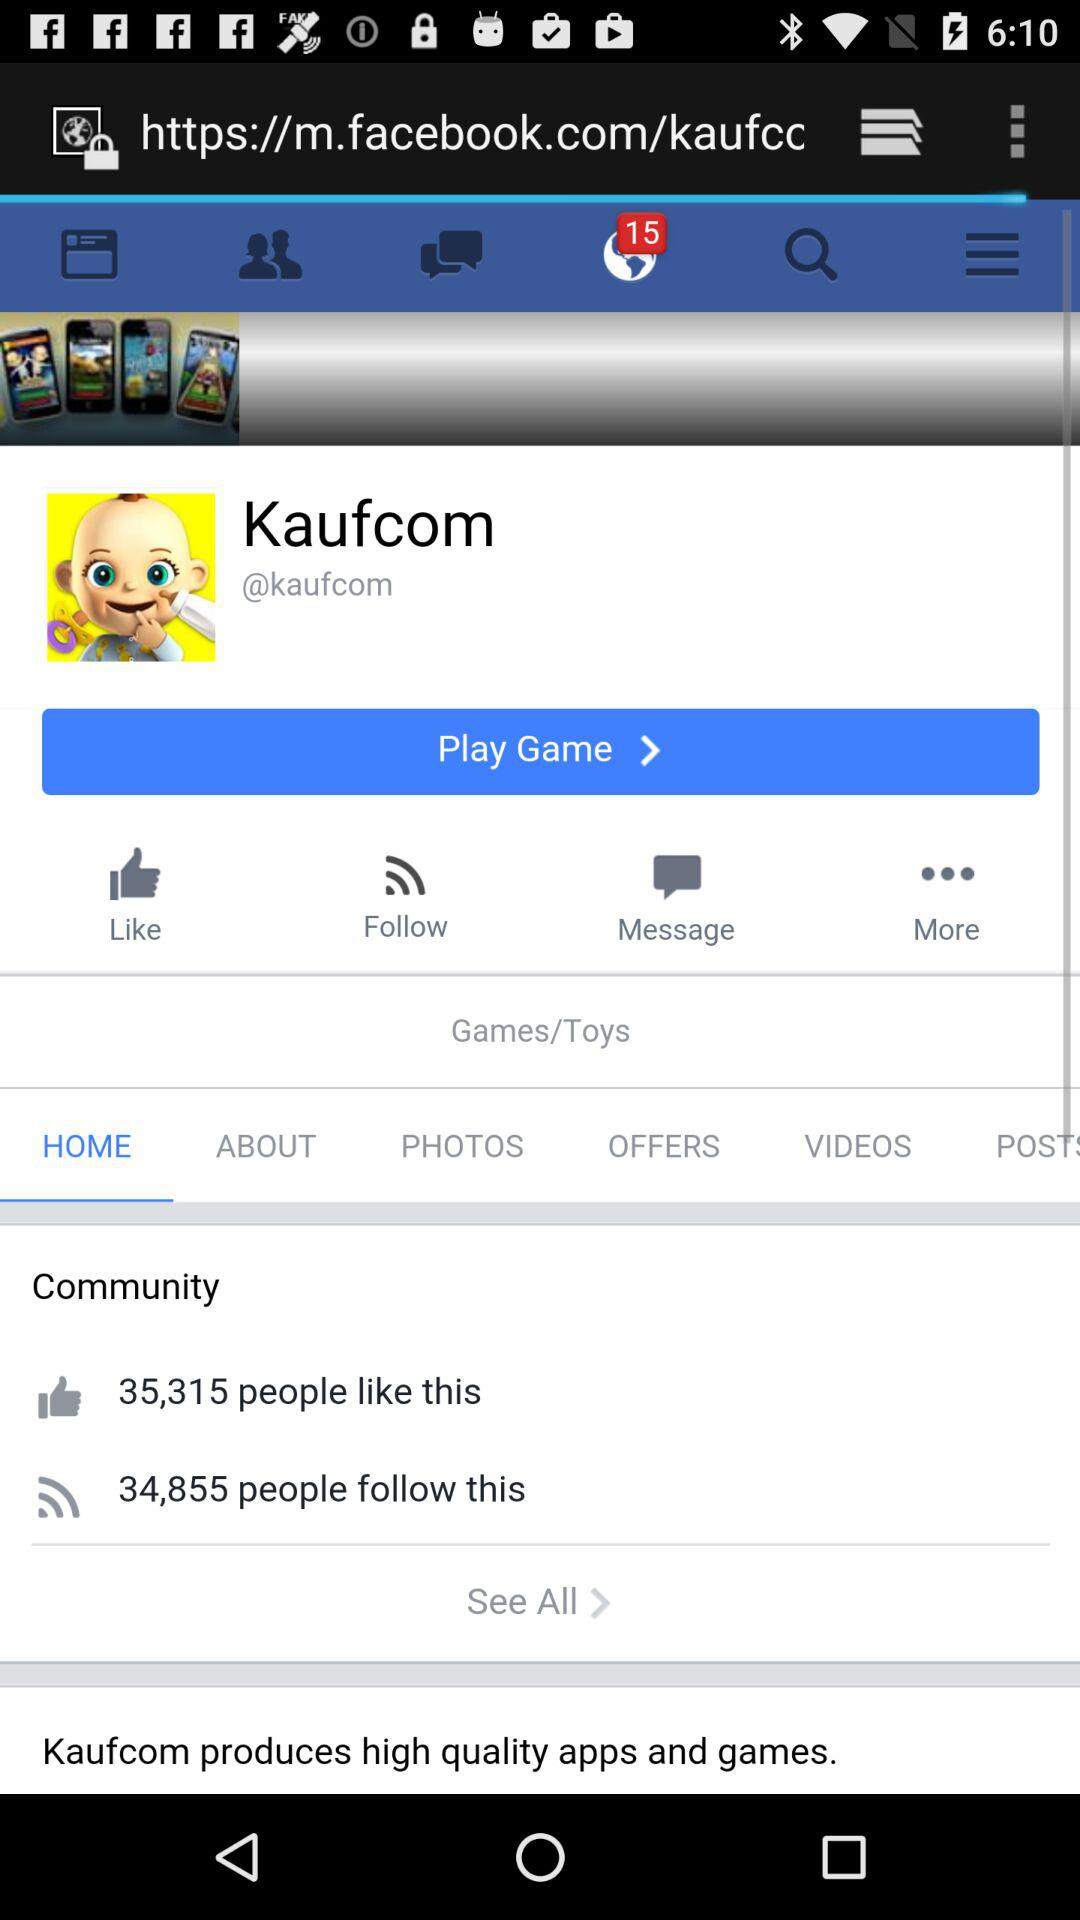How many people have followed "Kaufcom"? There are 34,855 people who have followed "Kaufcom". 